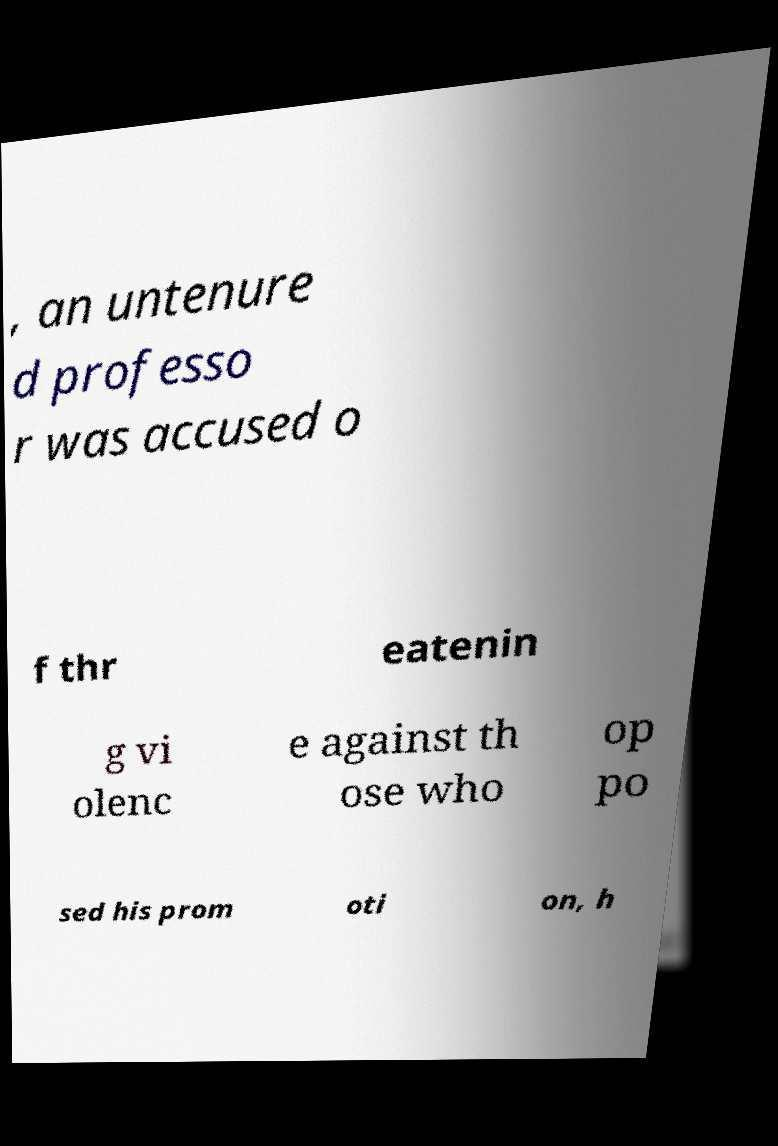Could you extract and type out the text from this image? , an untenure d professo r was accused o f thr eatenin g vi olenc e against th ose who op po sed his prom oti on, h 